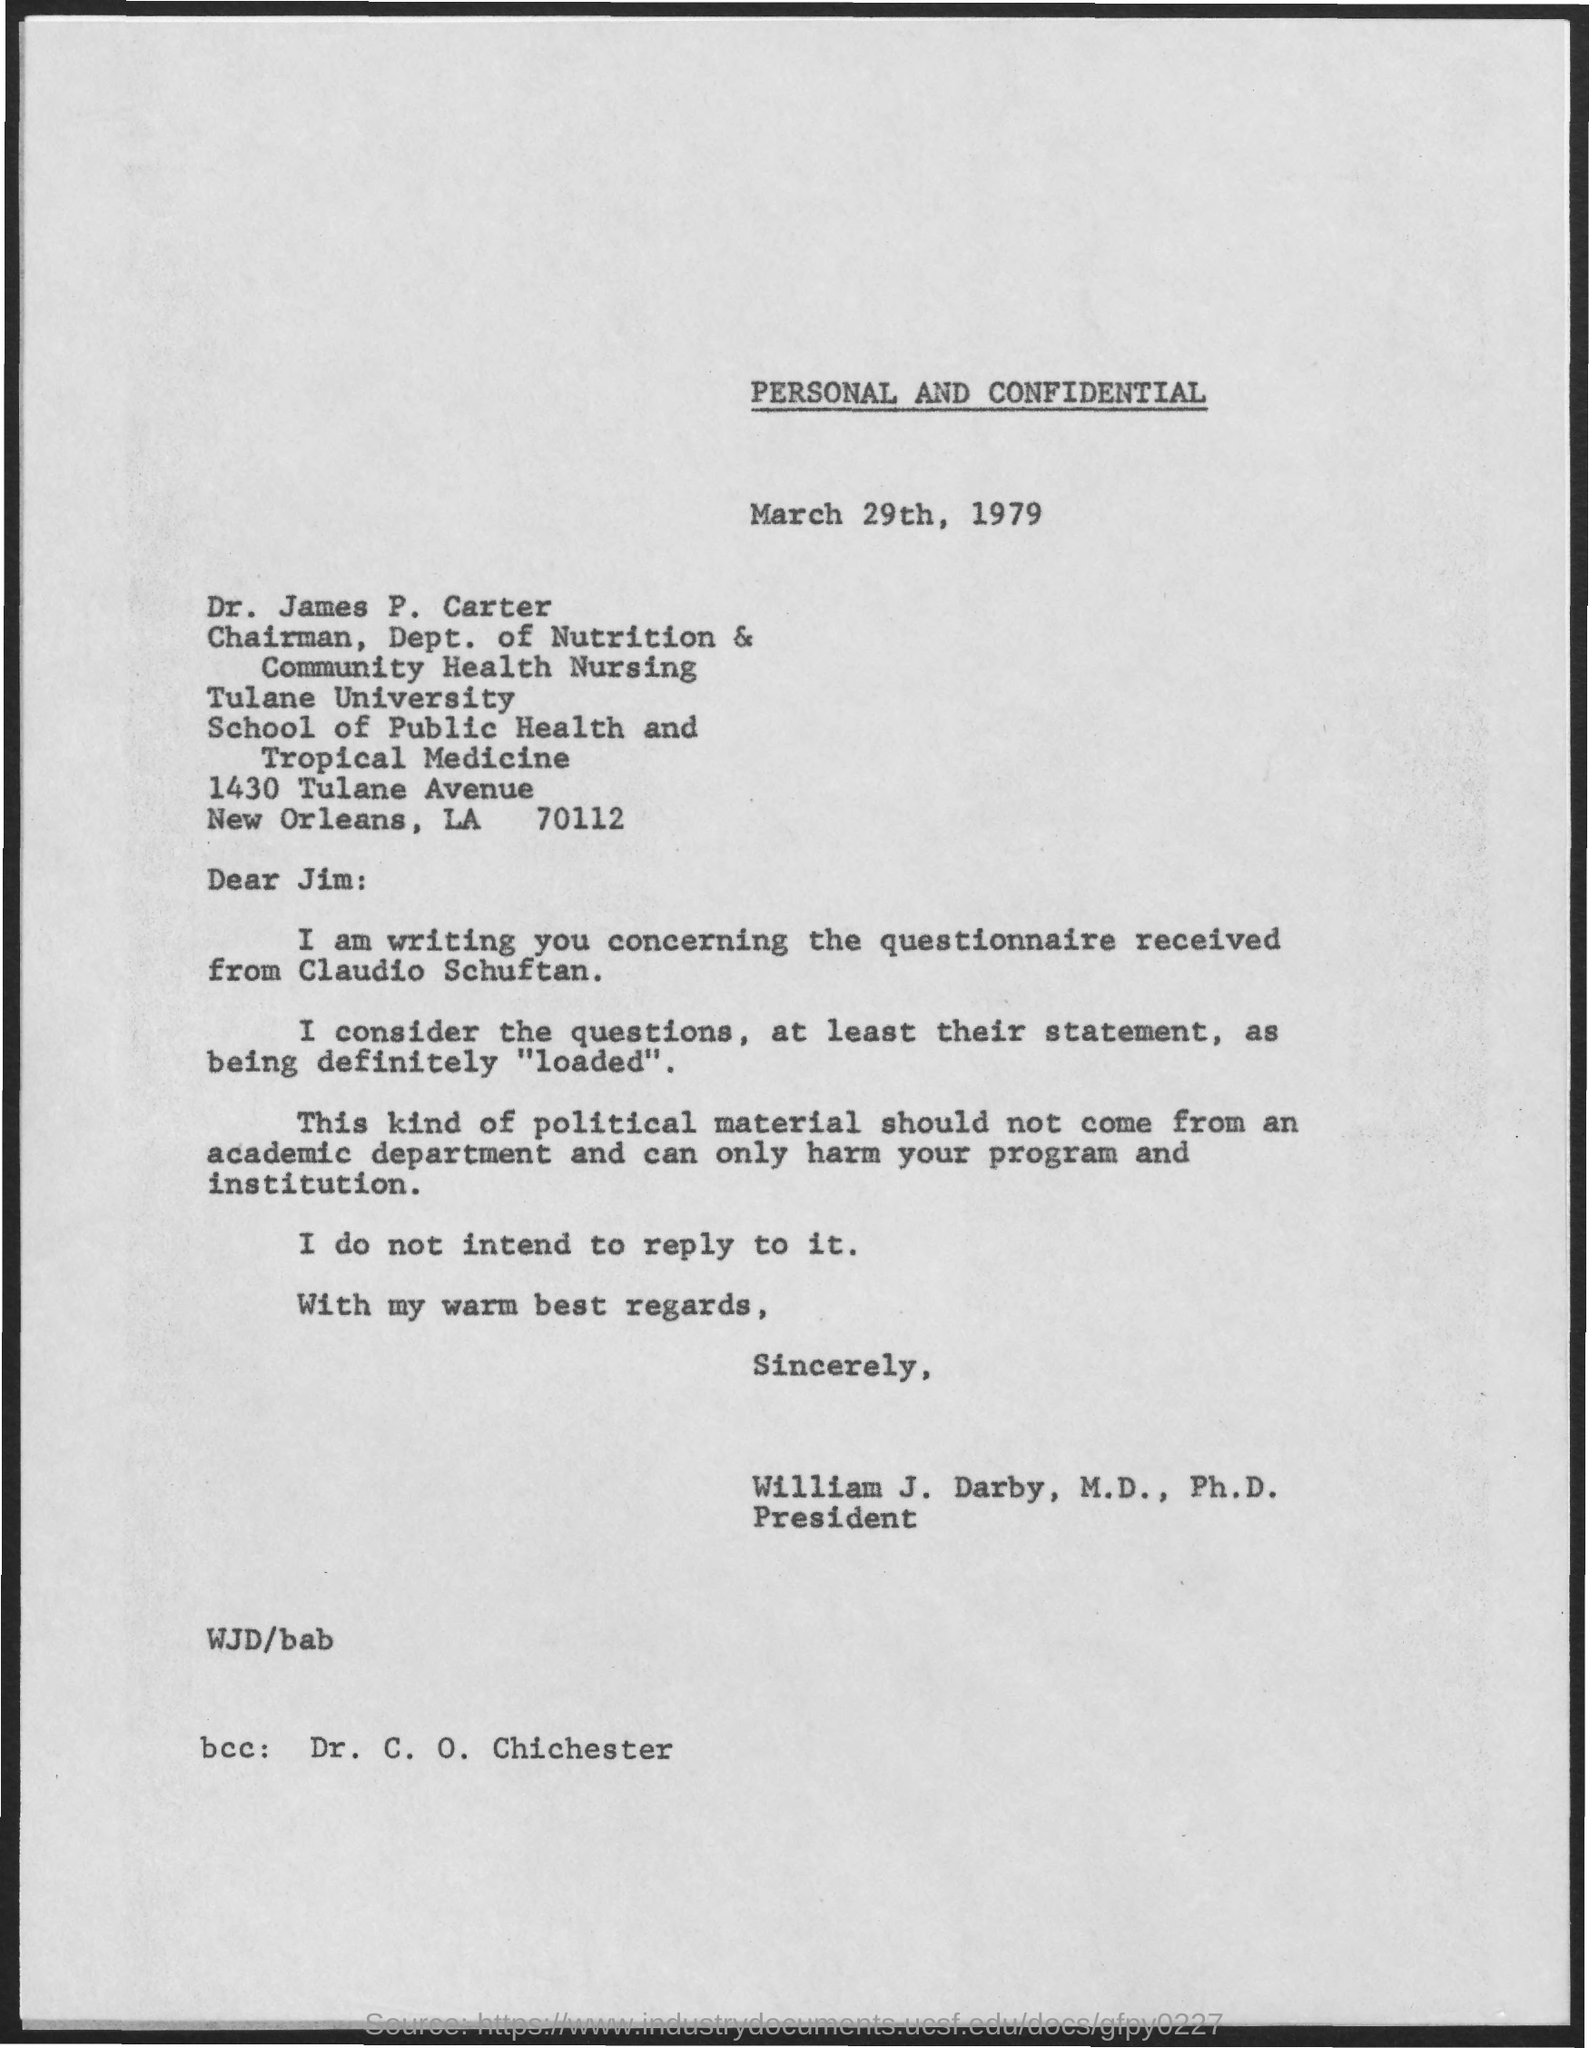Outline some significant characteristics in this image. Dr. C. O. Chichester is mentioned in the BCC. The name of Tulane University is... Dr. James P. Carter is the chairman of the Department of Nutrition and Community Health Nursing. The letter is written by William J. Darby, M.D., Ph.D. The date mentioned is March 29th, 1979. 